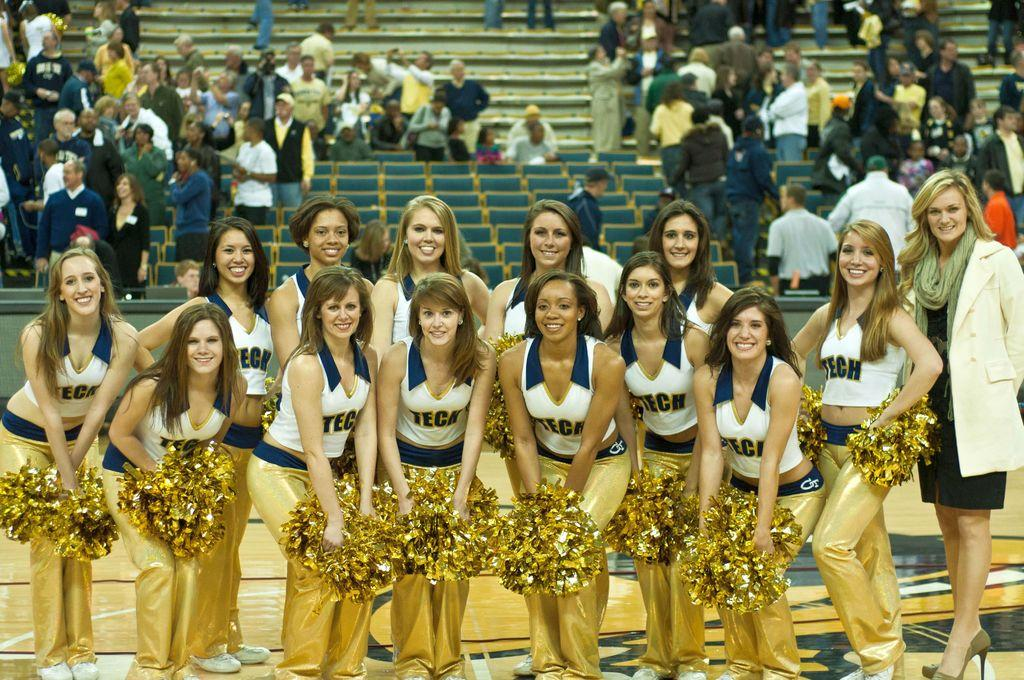Provide a one-sentence caption for the provided image. A group of cheerleaders for TECH with a crowd behind. 